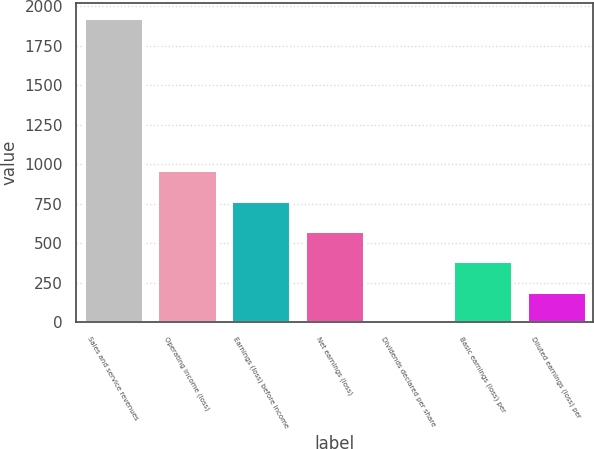Convert chart to OTSL. <chart><loc_0><loc_0><loc_500><loc_500><bar_chart><fcel>Sales and service revenues<fcel>Operating income (loss)<fcel>Earnings (loss) before income<fcel>Net earnings (loss)<fcel>Dividends declared per share<fcel>Basic earnings (loss) per<fcel>Diluted earnings (loss) per<nl><fcel>1927<fcel>963.7<fcel>771.04<fcel>578.38<fcel>0.4<fcel>385.72<fcel>193.06<nl></chart> 